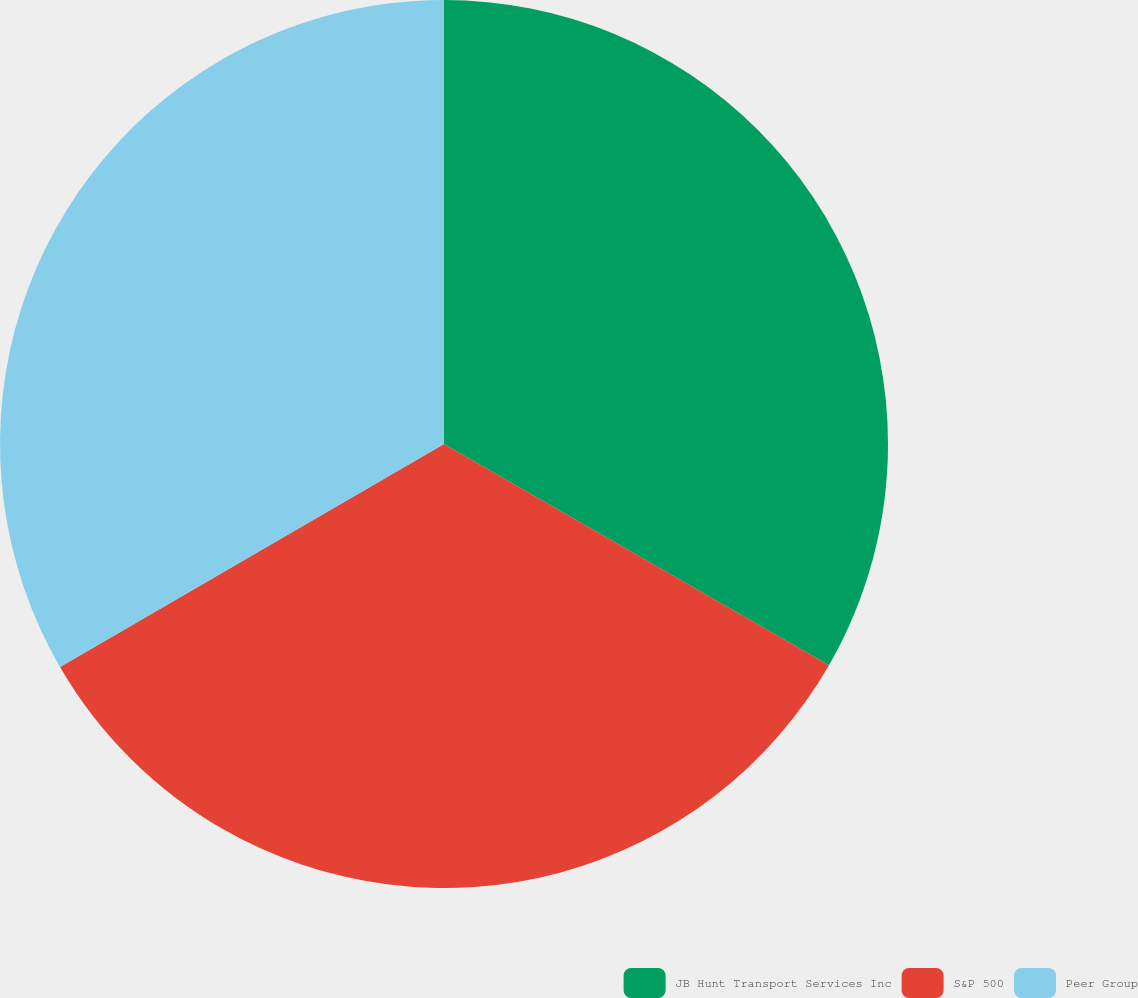<chart> <loc_0><loc_0><loc_500><loc_500><pie_chart><fcel>JB Hunt Transport Services Inc<fcel>S&P 500<fcel>Peer Group<nl><fcel>33.3%<fcel>33.33%<fcel>33.37%<nl></chart> 